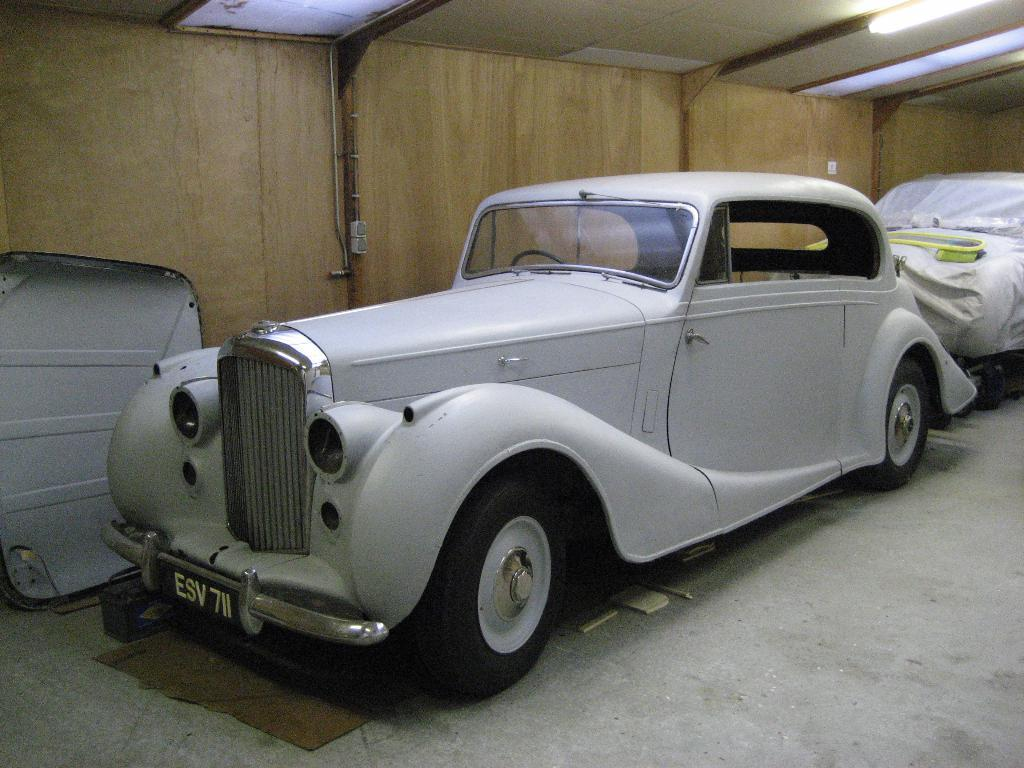What is the main subject in the foreground of the image? There is a car in the foreground of the image. Can you describe the second vehicle in the image? The second vehicle is behind the car and is covered with a sheet. What can be seen in the background of the image? There is a wall in the background of the image. How many bananas are hanging from the nerve in the image? There are no bananas or nerves present in the image. 